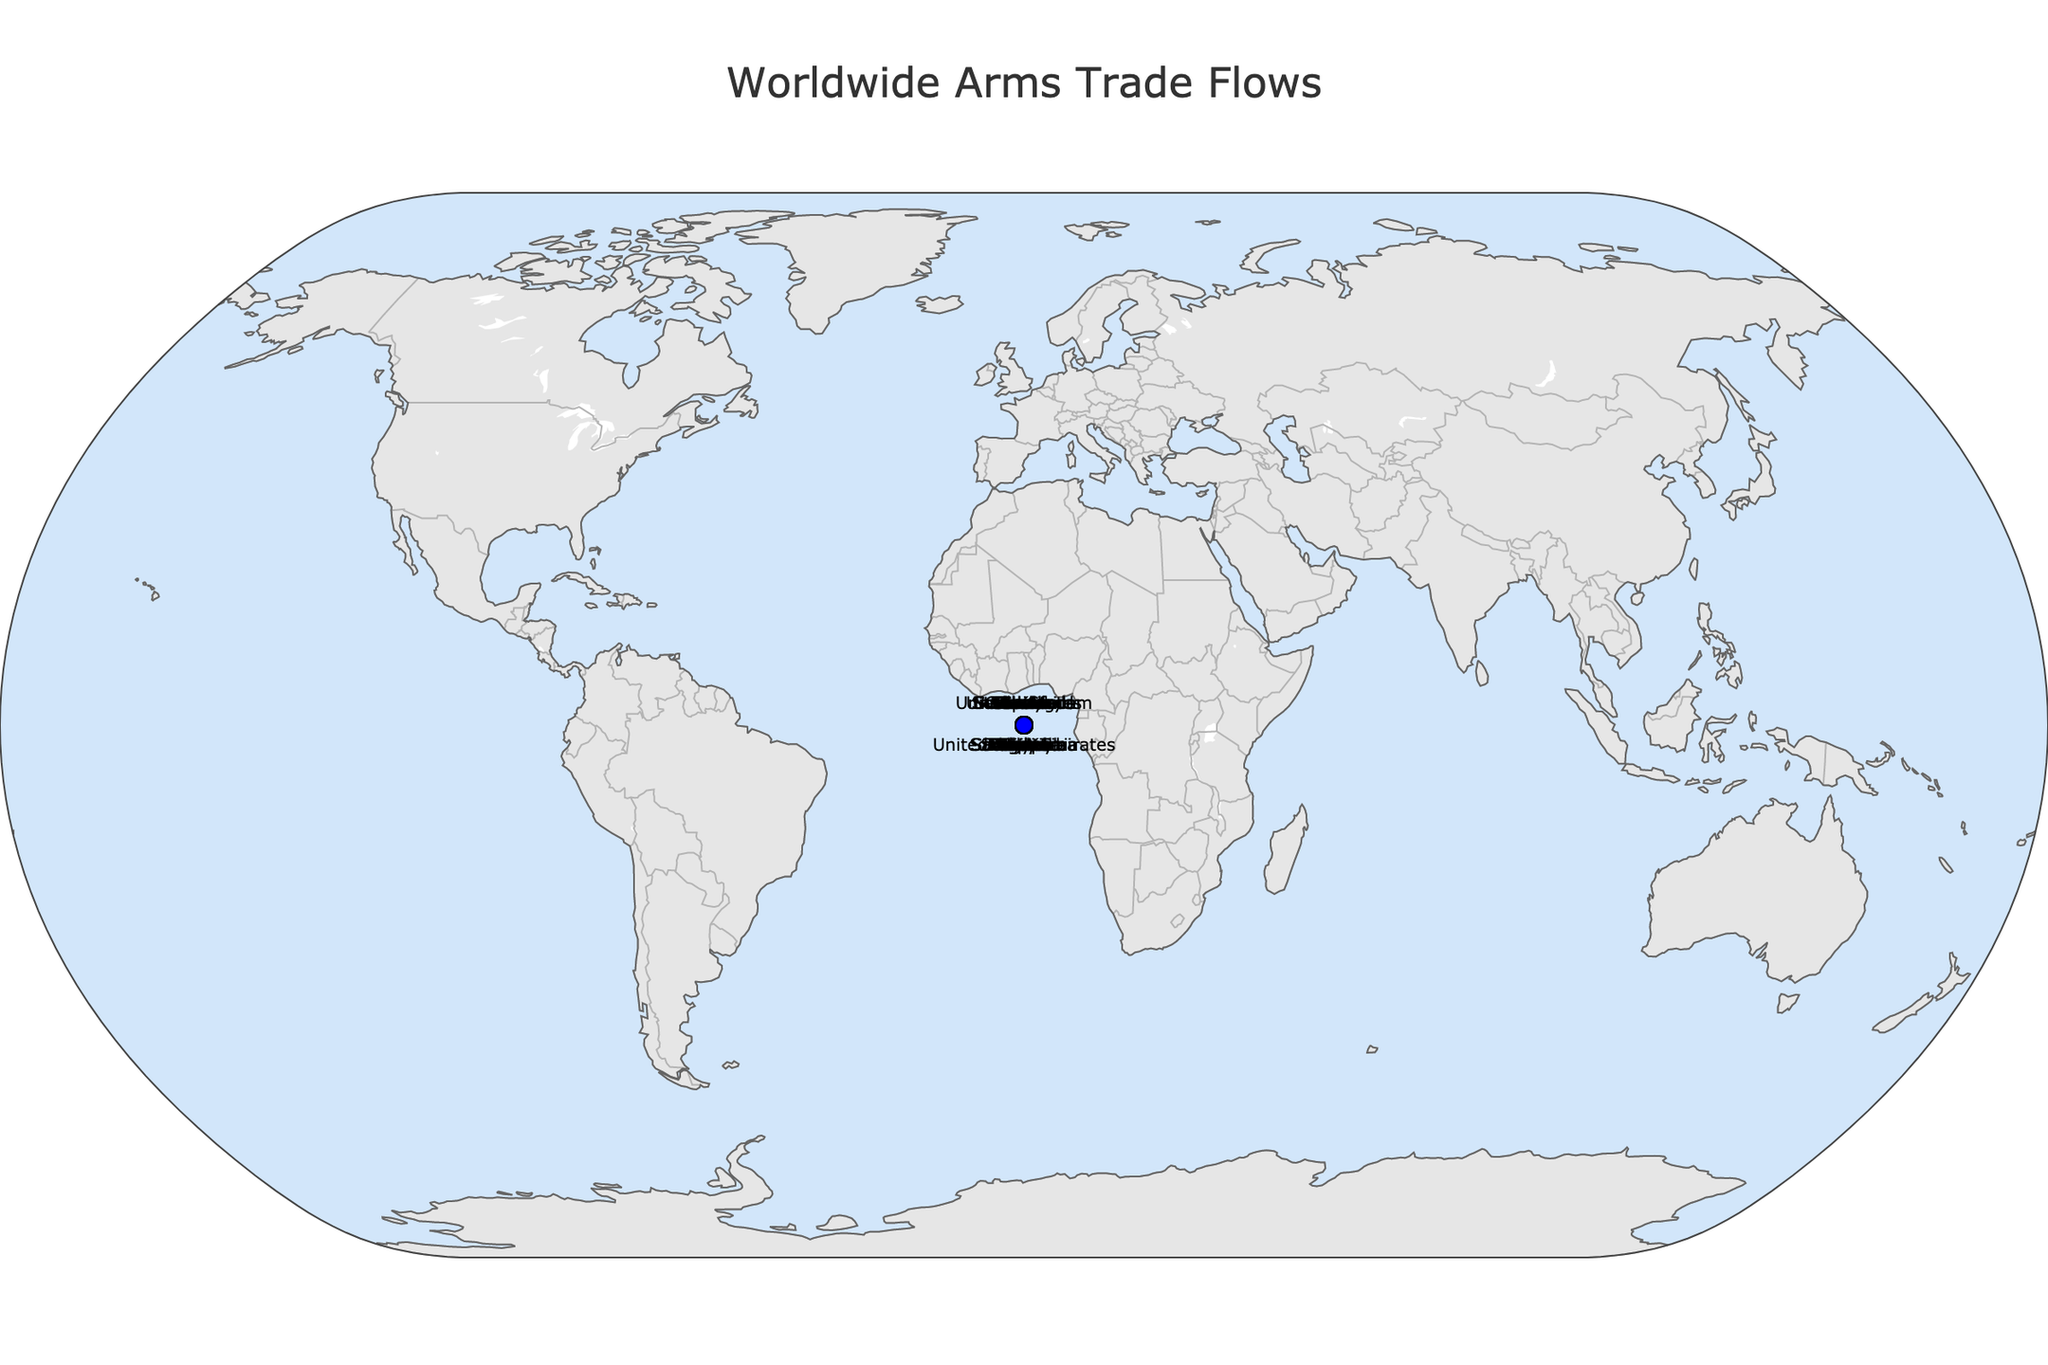What is the title of the plot? The title of the plot is clearly labeled at the top of the figure.
Answer: "Worldwide Arms Trade Flows" How many exporter countries are represented in the plot? Each exporter country is labeled with a marker and its name in red on the map. Counting each red marker or label will give the number of exporter countries.
Answer: 15 Which exporter has the highest value in arms trade, and who is the importer? The highest value in arms trade can be identified by looking at the labels with the largest numeric value in USD millions. The corresponding exporter and importer labels will provide the answer.
Answer: United States to Saudi Arabia Between France and Germany, which country exports more arms, and by how much? The trade values for each exporter can be found by looking at the labels next to "France" and "Germany." The difference is found by subtracting the smaller value from the larger value.
Answer: France exports more arms by $300 million What is the total value of arms exported by Italy, Spain, and Israel combined? Add the export values of Italy ($800 million), Spain ($650 million), and Israel ($950 million) to get the total value.
Answer: $2400 million Which importers receive arms from European countries (United Kingdom, Germany, France, etc.) in this plot? Identify all importers linked to exporters from European countries such as the United Kingdom, Germany, and France. Based on the plot, check each link to determine which importers correspond.
Answer: Japan, South Korea, Egypt, Turkey, Poland, Brazil Compare the trade values of arms exported by the United Kingdom and China. Which exporter has the higher value and by how much? Look at the arms trade values for the United Kingdom ($1200 million) and China ($1400 million). Subtract the smaller value from the larger value to find the difference.
Answer: China has a higher value by $200 million What is the smallest value of arms trade listed in the plot, and which countries are involved? The smallest trade value can be found by looking for the lowest numeric value in USD millions on the figure. Identify the corresponding exporter and importer labels.
Answer: South Africa to Malaysia, $300 million Which continent has the most importers in this plot? Identify the geographic locations of all importers and count how many importers are located on each continent. The continent with the highest count will be the answer.
Answer: Asia Are there any importers and exporters involving South American countries? If so, who are they, and what are the trade values? Check the labels to see if there are any South American countries listed as either exporters or importers within the plot. Determine the involved parties and their respective trade values.
Answer: Spain exports to Brazil, $650 million 